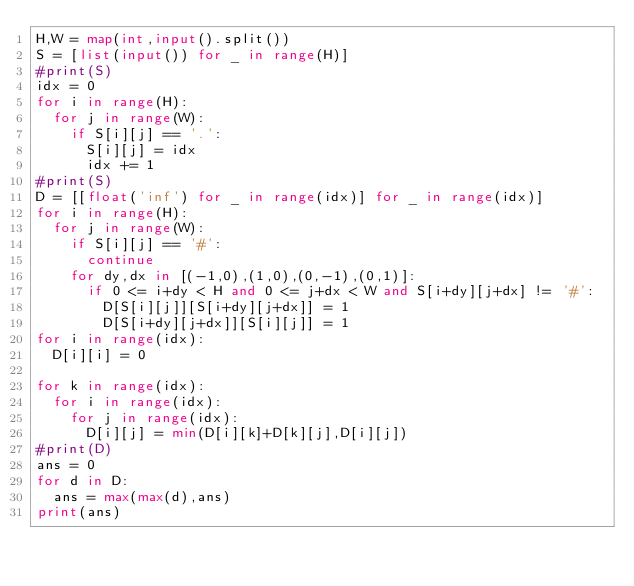<code> <loc_0><loc_0><loc_500><loc_500><_Python_>H,W = map(int,input().split())
S = [list(input()) for _ in range(H)]
#print(S)
idx = 0
for i in range(H):
  for j in range(W):
    if S[i][j] == '.':
      S[i][j] = idx
      idx += 1
#print(S)
D = [[float('inf') for _ in range(idx)] for _ in range(idx)]
for i in range(H):
  for j in range(W):
    if S[i][j] == '#':
      continue
    for dy,dx in [(-1,0),(1,0),(0,-1),(0,1)]:
      if 0 <= i+dy < H and 0 <= j+dx < W and S[i+dy][j+dx] != '#':
        D[S[i][j]][S[i+dy][j+dx]] = 1
        D[S[i+dy][j+dx]][S[i][j]] = 1
for i in range(idx):
  D[i][i] = 0

for k in range(idx):
  for i in range(idx):
    for j in range(idx):
      D[i][j] = min(D[i][k]+D[k][j],D[i][j])
#print(D)
ans = 0
for d in D:
  ans = max(max(d),ans)
print(ans)</code> 